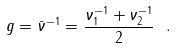<formula> <loc_0><loc_0><loc_500><loc_500>g = \bar { \nu } ^ { - 1 } = \frac { \nu _ { 1 } ^ { - 1 } + \nu _ { 2 } ^ { - 1 } } { 2 } \ .</formula> 